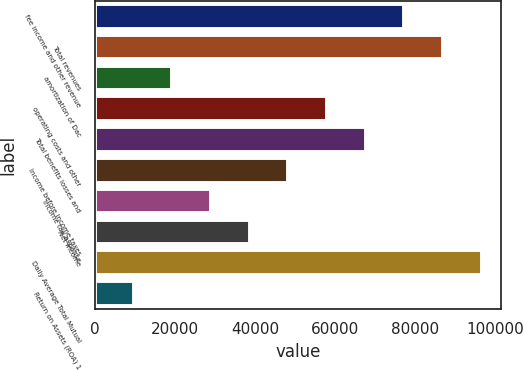<chart> <loc_0><loc_0><loc_500><loc_500><bar_chart><fcel>fee income and other revenue<fcel>Total revenues<fcel>amortization of Dac<fcel>operating costs and other<fcel>Total benefits losses and<fcel>Income before income taxes<fcel>income tax expense<fcel>Net income<fcel>Daily Average Total Mutual<fcel>Return on Assets (ROA) 1<nl><fcel>77254.6<fcel>86910.3<fcel>19320.5<fcel>57943.2<fcel>67598.9<fcel>48287.6<fcel>28976.2<fcel>38631.9<fcel>96566<fcel>9664.79<nl></chart> 